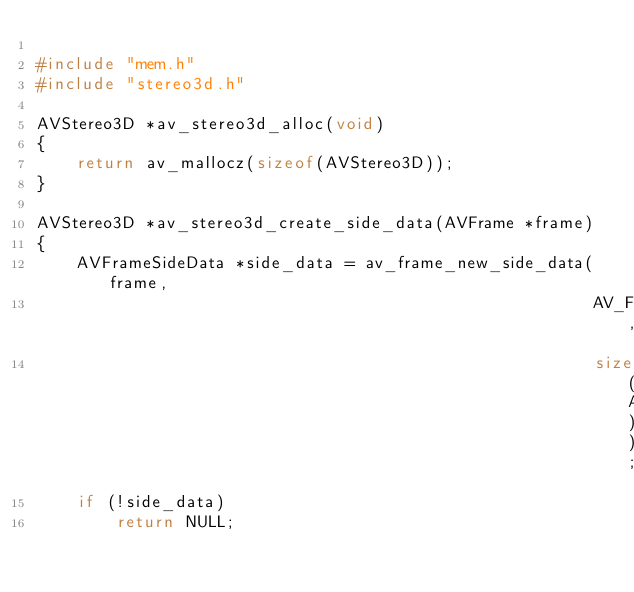Convert code to text. <code><loc_0><loc_0><loc_500><loc_500><_C_>
#include "mem.h"
#include "stereo3d.h"

AVStereo3D *av_stereo3d_alloc(void)
{
    return av_mallocz(sizeof(AVStereo3D));
}

AVStereo3D *av_stereo3d_create_side_data(AVFrame *frame)
{
    AVFrameSideData *side_data = av_frame_new_side_data(frame,
                                                        AV_FRAME_DATA_STEREO3D,
                                                        sizeof(AVStereo3D));
    if (!side_data)
        return NULL;
</code> 